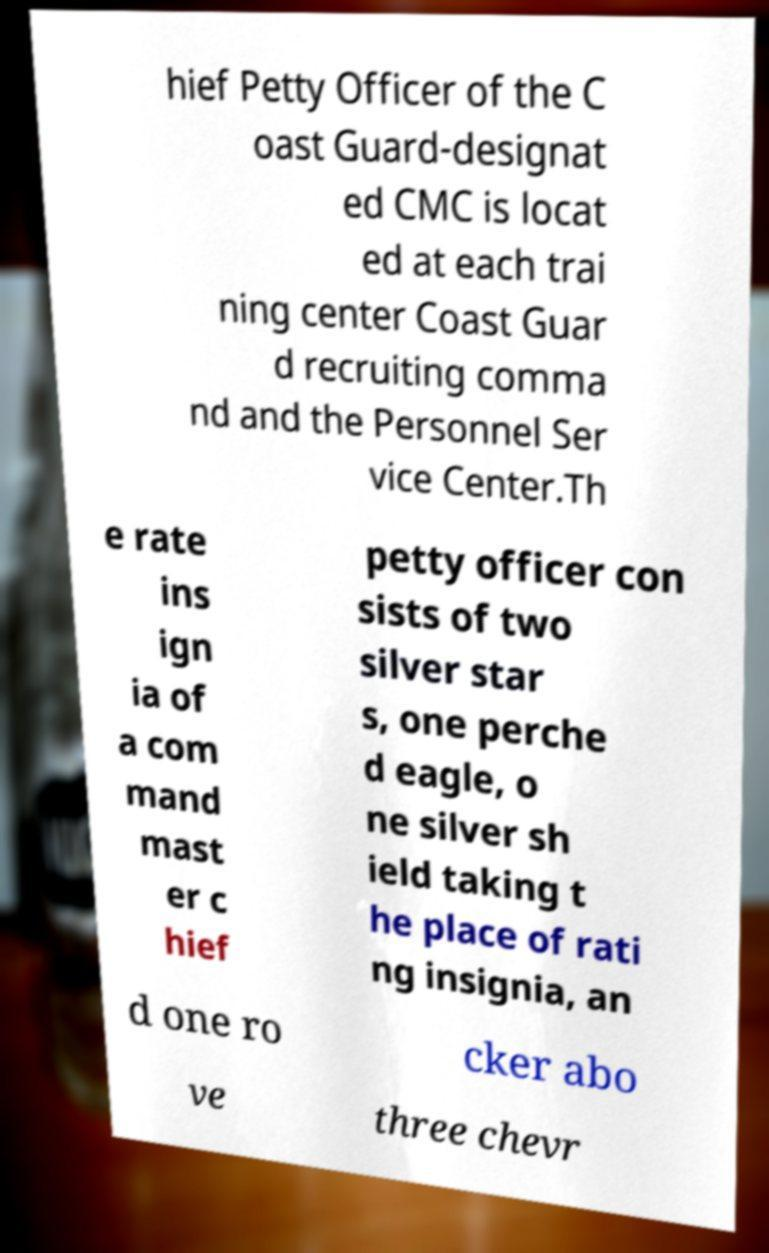I need the written content from this picture converted into text. Can you do that? hief Petty Officer of the C oast Guard-designat ed CMC is locat ed at each trai ning center Coast Guar d recruiting comma nd and the Personnel Ser vice Center.Th e rate ins ign ia of a com mand mast er c hief petty officer con sists of two silver star s, one perche d eagle, o ne silver sh ield taking t he place of rati ng insignia, an d one ro cker abo ve three chevr 